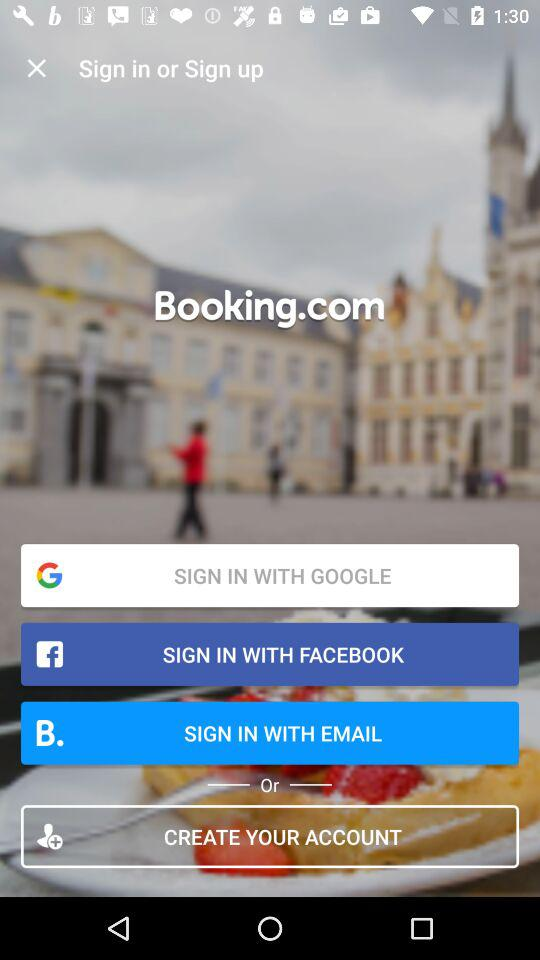Which accounts can I use to sign up? You can sign up with "GOOGLE", "FACEBOOK" and "EMAIL". 